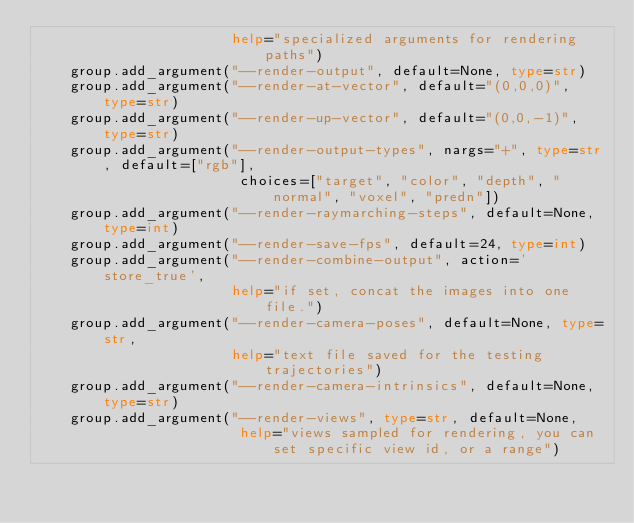<code> <loc_0><loc_0><loc_500><loc_500><_Python_>                       help="specialized arguments for rendering paths")
    group.add_argument("--render-output", default=None, type=str)
    group.add_argument("--render-at-vector", default="(0,0,0)", type=str)
    group.add_argument("--render-up-vector", default="(0,0,-1)", type=str)
    group.add_argument("--render-output-types", nargs="+", type=str, default=["rgb"], 
                        choices=["target", "color", "depth", "normal", "voxel", "predn"])
    group.add_argument("--render-raymarching-steps", default=None, type=int)
    group.add_argument("--render-save-fps", default=24, type=int)
    group.add_argument("--render-combine-output", action='store_true', 
                       help="if set, concat the images into one file.")
    group.add_argument("--render-camera-poses", default=None, type=str,
                       help="text file saved for the testing trajectories")
    group.add_argument("--render-camera-intrinsics", default=None, type=str)
    group.add_argument("--render-views", type=str, default=None, 
                        help="views sampled for rendering, you can set specific view id, or a range")</code> 